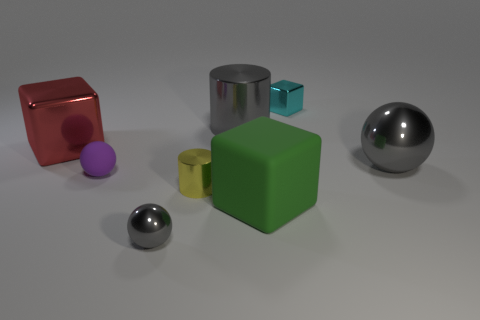Subtract all gray cylinders. How many gray spheres are left? 2 Subtract all big blocks. How many blocks are left? 1 Add 1 big spheres. How many objects exist? 9 Subtract all blocks. How many objects are left? 5 Subtract all large gray metallic balls. Subtract all big green matte objects. How many objects are left? 6 Add 7 cyan objects. How many cyan objects are left? 8 Add 6 small spheres. How many small spheres exist? 8 Subtract 1 red cubes. How many objects are left? 7 